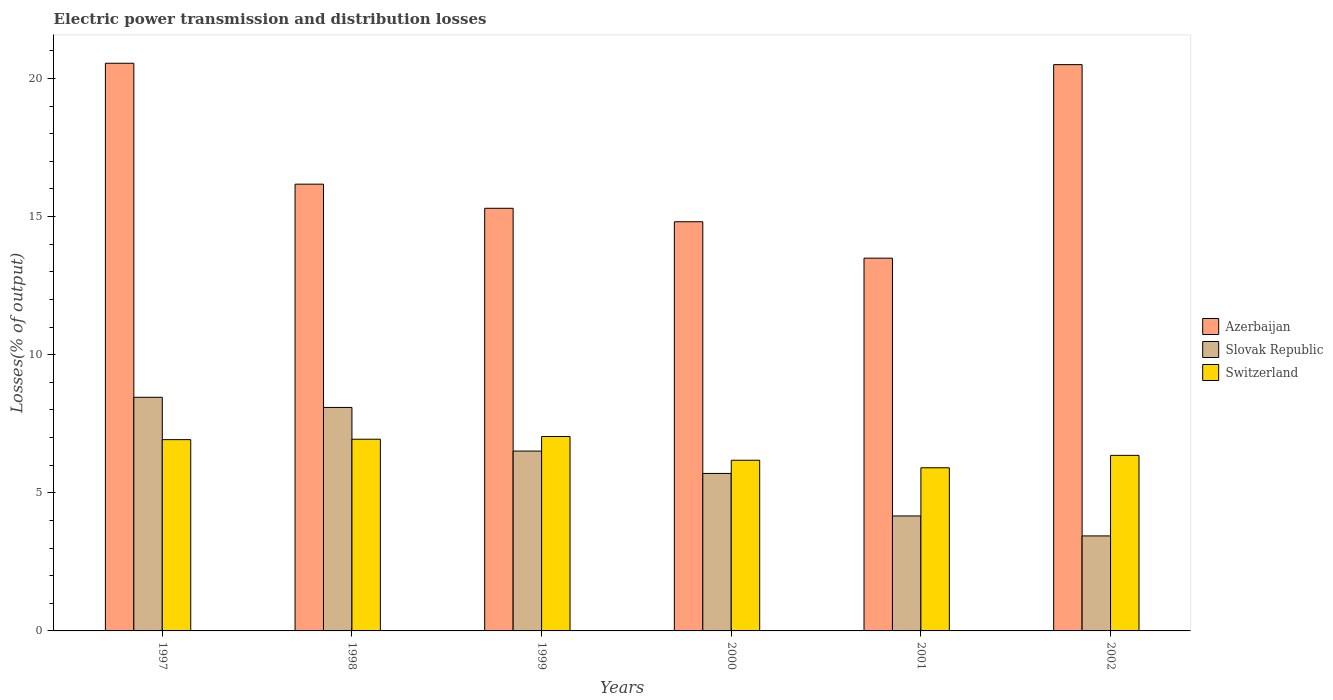Are the number of bars on each tick of the X-axis equal?
Provide a succinct answer. Yes. How many bars are there on the 2nd tick from the left?
Ensure brevity in your answer.  3. How many bars are there on the 6th tick from the right?
Your answer should be very brief. 3. What is the label of the 3rd group of bars from the left?
Give a very brief answer. 1999. What is the electric power transmission and distribution losses in Switzerland in 1999?
Make the answer very short. 7.04. Across all years, what is the maximum electric power transmission and distribution losses in Azerbaijan?
Your answer should be compact. 20.55. Across all years, what is the minimum electric power transmission and distribution losses in Switzerland?
Make the answer very short. 5.91. In which year was the electric power transmission and distribution losses in Switzerland maximum?
Your response must be concise. 1999. What is the total electric power transmission and distribution losses in Switzerland in the graph?
Your response must be concise. 39.34. What is the difference between the electric power transmission and distribution losses in Switzerland in 1998 and that in 2000?
Keep it short and to the point. 0.76. What is the difference between the electric power transmission and distribution losses in Switzerland in 2000 and the electric power transmission and distribution losses in Azerbaijan in 1998?
Keep it short and to the point. -9.99. What is the average electric power transmission and distribution losses in Azerbaijan per year?
Your answer should be very brief. 16.81. In the year 1998, what is the difference between the electric power transmission and distribution losses in Slovak Republic and electric power transmission and distribution losses in Switzerland?
Give a very brief answer. 1.15. What is the ratio of the electric power transmission and distribution losses in Azerbaijan in 2000 to that in 2002?
Give a very brief answer. 0.72. What is the difference between the highest and the second highest electric power transmission and distribution losses in Azerbaijan?
Your response must be concise. 0.05. What is the difference between the highest and the lowest electric power transmission and distribution losses in Slovak Republic?
Offer a very short reply. 5.02. In how many years, is the electric power transmission and distribution losses in Slovak Republic greater than the average electric power transmission and distribution losses in Slovak Republic taken over all years?
Your answer should be compact. 3. What does the 2nd bar from the left in 2002 represents?
Offer a very short reply. Slovak Republic. What does the 2nd bar from the right in 1997 represents?
Make the answer very short. Slovak Republic. Are all the bars in the graph horizontal?
Offer a very short reply. No. How many years are there in the graph?
Make the answer very short. 6. Does the graph contain any zero values?
Your answer should be very brief. No. How many legend labels are there?
Ensure brevity in your answer.  3. How are the legend labels stacked?
Your answer should be compact. Vertical. What is the title of the graph?
Your answer should be compact. Electric power transmission and distribution losses. Does "Cambodia" appear as one of the legend labels in the graph?
Provide a succinct answer. No. What is the label or title of the X-axis?
Your answer should be compact. Years. What is the label or title of the Y-axis?
Ensure brevity in your answer.  Losses(% of output). What is the Losses(% of output) in Azerbaijan in 1997?
Your response must be concise. 20.55. What is the Losses(% of output) in Slovak Republic in 1997?
Provide a short and direct response. 8.46. What is the Losses(% of output) of Switzerland in 1997?
Provide a succinct answer. 6.92. What is the Losses(% of output) in Azerbaijan in 1998?
Your answer should be very brief. 16.17. What is the Losses(% of output) of Slovak Republic in 1998?
Make the answer very short. 8.09. What is the Losses(% of output) in Switzerland in 1998?
Your answer should be very brief. 6.94. What is the Losses(% of output) in Azerbaijan in 1999?
Offer a very short reply. 15.3. What is the Losses(% of output) in Slovak Republic in 1999?
Provide a succinct answer. 6.51. What is the Losses(% of output) in Switzerland in 1999?
Your response must be concise. 7.04. What is the Losses(% of output) of Azerbaijan in 2000?
Make the answer very short. 14.81. What is the Losses(% of output) in Slovak Republic in 2000?
Provide a succinct answer. 5.7. What is the Losses(% of output) in Switzerland in 2000?
Your answer should be compact. 6.18. What is the Losses(% of output) of Azerbaijan in 2001?
Provide a short and direct response. 13.49. What is the Losses(% of output) of Slovak Republic in 2001?
Your response must be concise. 4.16. What is the Losses(% of output) in Switzerland in 2001?
Your response must be concise. 5.91. What is the Losses(% of output) in Azerbaijan in 2002?
Your response must be concise. 20.5. What is the Losses(% of output) of Slovak Republic in 2002?
Offer a terse response. 3.44. What is the Losses(% of output) in Switzerland in 2002?
Provide a succinct answer. 6.36. Across all years, what is the maximum Losses(% of output) in Azerbaijan?
Ensure brevity in your answer.  20.55. Across all years, what is the maximum Losses(% of output) of Slovak Republic?
Your answer should be very brief. 8.46. Across all years, what is the maximum Losses(% of output) in Switzerland?
Make the answer very short. 7.04. Across all years, what is the minimum Losses(% of output) in Azerbaijan?
Offer a very short reply. 13.49. Across all years, what is the minimum Losses(% of output) of Slovak Republic?
Make the answer very short. 3.44. Across all years, what is the minimum Losses(% of output) of Switzerland?
Provide a succinct answer. 5.91. What is the total Losses(% of output) of Azerbaijan in the graph?
Your answer should be compact. 100.84. What is the total Losses(% of output) of Slovak Republic in the graph?
Your response must be concise. 36.36. What is the total Losses(% of output) in Switzerland in the graph?
Provide a short and direct response. 39.34. What is the difference between the Losses(% of output) in Azerbaijan in 1997 and that in 1998?
Offer a terse response. 4.38. What is the difference between the Losses(% of output) in Slovak Republic in 1997 and that in 1998?
Offer a very short reply. 0.37. What is the difference between the Losses(% of output) of Switzerland in 1997 and that in 1998?
Provide a succinct answer. -0.02. What is the difference between the Losses(% of output) in Azerbaijan in 1997 and that in 1999?
Provide a short and direct response. 5.25. What is the difference between the Losses(% of output) in Slovak Republic in 1997 and that in 1999?
Keep it short and to the point. 1.95. What is the difference between the Losses(% of output) in Switzerland in 1997 and that in 1999?
Provide a succinct answer. -0.11. What is the difference between the Losses(% of output) of Azerbaijan in 1997 and that in 2000?
Offer a very short reply. 5.74. What is the difference between the Losses(% of output) of Slovak Republic in 1997 and that in 2000?
Your answer should be compact. 2.76. What is the difference between the Losses(% of output) in Switzerland in 1997 and that in 2000?
Offer a very short reply. 0.75. What is the difference between the Losses(% of output) in Azerbaijan in 1997 and that in 2001?
Your answer should be compact. 7.06. What is the difference between the Losses(% of output) of Slovak Republic in 1997 and that in 2001?
Your response must be concise. 4.3. What is the difference between the Losses(% of output) of Switzerland in 1997 and that in 2001?
Give a very brief answer. 1.02. What is the difference between the Losses(% of output) in Azerbaijan in 1997 and that in 2002?
Your answer should be very brief. 0.05. What is the difference between the Losses(% of output) in Slovak Republic in 1997 and that in 2002?
Your response must be concise. 5.02. What is the difference between the Losses(% of output) in Switzerland in 1997 and that in 2002?
Give a very brief answer. 0.57. What is the difference between the Losses(% of output) in Azerbaijan in 1998 and that in 1999?
Your response must be concise. 0.87. What is the difference between the Losses(% of output) of Slovak Republic in 1998 and that in 1999?
Give a very brief answer. 1.58. What is the difference between the Losses(% of output) in Switzerland in 1998 and that in 1999?
Your answer should be very brief. -0.1. What is the difference between the Losses(% of output) in Azerbaijan in 1998 and that in 2000?
Provide a short and direct response. 1.36. What is the difference between the Losses(% of output) in Slovak Republic in 1998 and that in 2000?
Keep it short and to the point. 2.39. What is the difference between the Losses(% of output) of Switzerland in 1998 and that in 2000?
Your answer should be compact. 0.76. What is the difference between the Losses(% of output) of Azerbaijan in 1998 and that in 2001?
Ensure brevity in your answer.  2.68. What is the difference between the Losses(% of output) of Slovak Republic in 1998 and that in 2001?
Keep it short and to the point. 3.93. What is the difference between the Losses(% of output) in Switzerland in 1998 and that in 2001?
Your answer should be compact. 1.03. What is the difference between the Losses(% of output) in Azerbaijan in 1998 and that in 2002?
Give a very brief answer. -4.33. What is the difference between the Losses(% of output) in Slovak Republic in 1998 and that in 2002?
Your answer should be compact. 4.65. What is the difference between the Losses(% of output) in Switzerland in 1998 and that in 2002?
Your answer should be very brief. 0.58. What is the difference between the Losses(% of output) in Azerbaijan in 1999 and that in 2000?
Provide a short and direct response. 0.49. What is the difference between the Losses(% of output) of Slovak Republic in 1999 and that in 2000?
Keep it short and to the point. 0.81. What is the difference between the Losses(% of output) of Switzerland in 1999 and that in 2000?
Offer a very short reply. 0.86. What is the difference between the Losses(% of output) in Azerbaijan in 1999 and that in 2001?
Offer a very short reply. 1.81. What is the difference between the Losses(% of output) of Slovak Republic in 1999 and that in 2001?
Your response must be concise. 2.35. What is the difference between the Losses(% of output) in Switzerland in 1999 and that in 2001?
Your response must be concise. 1.13. What is the difference between the Losses(% of output) of Azerbaijan in 1999 and that in 2002?
Your answer should be very brief. -5.2. What is the difference between the Losses(% of output) in Slovak Republic in 1999 and that in 2002?
Provide a short and direct response. 3.07. What is the difference between the Losses(% of output) in Switzerland in 1999 and that in 2002?
Provide a succinct answer. 0.68. What is the difference between the Losses(% of output) in Azerbaijan in 2000 and that in 2001?
Offer a terse response. 1.32. What is the difference between the Losses(% of output) of Slovak Republic in 2000 and that in 2001?
Provide a succinct answer. 1.54. What is the difference between the Losses(% of output) in Switzerland in 2000 and that in 2001?
Ensure brevity in your answer.  0.27. What is the difference between the Losses(% of output) of Azerbaijan in 2000 and that in 2002?
Your response must be concise. -5.69. What is the difference between the Losses(% of output) of Slovak Republic in 2000 and that in 2002?
Keep it short and to the point. 2.26. What is the difference between the Losses(% of output) of Switzerland in 2000 and that in 2002?
Ensure brevity in your answer.  -0.18. What is the difference between the Losses(% of output) in Azerbaijan in 2001 and that in 2002?
Provide a short and direct response. -7.01. What is the difference between the Losses(% of output) in Slovak Republic in 2001 and that in 2002?
Provide a short and direct response. 0.72. What is the difference between the Losses(% of output) in Switzerland in 2001 and that in 2002?
Give a very brief answer. -0.45. What is the difference between the Losses(% of output) of Azerbaijan in 1997 and the Losses(% of output) of Slovak Republic in 1998?
Give a very brief answer. 12.46. What is the difference between the Losses(% of output) of Azerbaijan in 1997 and the Losses(% of output) of Switzerland in 1998?
Your answer should be very brief. 13.61. What is the difference between the Losses(% of output) of Slovak Republic in 1997 and the Losses(% of output) of Switzerland in 1998?
Your response must be concise. 1.52. What is the difference between the Losses(% of output) of Azerbaijan in 1997 and the Losses(% of output) of Slovak Republic in 1999?
Provide a succinct answer. 14.04. What is the difference between the Losses(% of output) of Azerbaijan in 1997 and the Losses(% of output) of Switzerland in 1999?
Ensure brevity in your answer.  13.51. What is the difference between the Losses(% of output) of Slovak Republic in 1997 and the Losses(% of output) of Switzerland in 1999?
Ensure brevity in your answer.  1.42. What is the difference between the Losses(% of output) of Azerbaijan in 1997 and the Losses(% of output) of Slovak Republic in 2000?
Make the answer very short. 14.85. What is the difference between the Losses(% of output) in Azerbaijan in 1997 and the Losses(% of output) in Switzerland in 2000?
Make the answer very short. 14.37. What is the difference between the Losses(% of output) in Slovak Republic in 1997 and the Losses(% of output) in Switzerland in 2000?
Make the answer very short. 2.28. What is the difference between the Losses(% of output) of Azerbaijan in 1997 and the Losses(% of output) of Slovak Republic in 2001?
Make the answer very short. 16.39. What is the difference between the Losses(% of output) of Azerbaijan in 1997 and the Losses(% of output) of Switzerland in 2001?
Provide a succinct answer. 14.64. What is the difference between the Losses(% of output) of Slovak Republic in 1997 and the Losses(% of output) of Switzerland in 2001?
Your response must be concise. 2.55. What is the difference between the Losses(% of output) in Azerbaijan in 1997 and the Losses(% of output) in Slovak Republic in 2002?
Your answer should be very brief. 17.11. What is the difference between the Losses(% of output) of Azerbaijan in 1997 and the Losses(% of output) of Switzerland in 2002?
Your answer should be compact. 14.2. What is the difference between the Losses(% of output) in Slovak Republic in 1997 and the Losses(% of output) in Switzerland in 2002?
Offer a terse response. 2.1. What is the difference between the Losses(% of output) in Azerbaijan in 1998 and the Losses(% of output) in Slovak Republic in 1999?
Your response must be concise. 9.66. What is the difference between the Losses(% of output) in Azerbaijan in 1998 and the Losses(% of output) in Switzerland in 1999?
Keep it short and to the point. 9.14. What is the difference between the Losses(% of output) of Slovak Republic in 1998 and the Losses(% of output) of Switzerland in 1999?
Offer a very short reply. 1.05. What is the difference between the Losses(% of output) of Azerbaijan in 1998 and the Losses(% of output) of Slovak Republic in 2000?
Offer a very short reply. 10.47. What is the difference between the Losses(% of output) of Azerbaijan in 1998 and the Losses(% of output) of Switzerland in 2000?
Offer a very short reply. 9.99. What is the difference between the Losses(% of output) of Slovak Republic in 1998 and the Losses(% of output) of Switzerland in 2000?
Make the answer very short. 1.91. What is the difference between the Losses(% of output) of Azerbaijan in 1998 and the Losses(% of output) of Slovak Republic in 2001?
Your answer should be very brief. 12.01. What is the difference between the Losses(% of output) of Azerbaijan in 1998 and the Losses(% of output) of Switzerland in 2001?
Make the answer very short. 10.27. What is the difference between the Losses(% of output) of Slovak Republic in 1998 and the Losses(% of output) of Switzerland in 2001?
Provide a succinct answer. 2.18. What is the difference between the Losses(% of output) in Azerbaijan in 1998 and the Losses(% of output) in Slovak Republic in 2002?
Keep it short and to the point. 12.73. What is the difference between the Losses(% of output) of Azerbaijan in 1998 and the Losses(% of output) of Switzerland in 2002?
Offer a terse response. 9.82. What is the difference between the Losses(% of output) of Slovak Republic in 1998 and the Losses(% of output) of Switzerland in 2002?
Provide a succinct answer. 1.74. What is the difference between the Losses(% of output) of Azerbaijan in 1999 and the Losses(% of output) of Slovak Republic in 2000?
Make the answer very short. 9.6. What is the difference between the Losses(% of output) of Azerbaijan in 1999 and the Losses(% of output) of Switzerland in 2000?
Your answer should be compact. 9.12. What is the difference between the Losses(% of output) in Slovak Republic in 1999 and the Losses(% of output) in Switzerland in 2000?
Make the answer very short. 0.33. What is the difference between the Losses(% of output) in Azerbaijan in 1999 and the Losses(% of output) in Slovak Republic in 2001?
Offer a terse response. 11.14. What is the difference between the Losses(% of output) in Azerbaijan in 1999 and the Losses(% of output) in Switzerland in 2001?
Give a very brief answer. 9.39. What is the difference between the Losses(% of output) of Slovak Republic in 1999 and the Losses(% of output) of Switzerland in 2001?
Keep it short and to the point. 0.6. What is the difference between the Losses(% of output) in Azerbaijan in 1999 and the Losses(% of output) in Slovak Republic in 2002?
Offer a very short reply. 11.86. What is the difference between the Losses(% of output) of Azerbaijan in 1999 and the Losses(% of output) of Switzerland in 2002?
Offer a very short reply. 8.94. What is the difference between the Losses(% of output) in Slovak Republic in 1999 and the Losses(% of output) in Switzerland in 2002?
Your answer should be very brief. 0.16. What is the difference between the Losses(% of output) in Azerbaijan in 2000 and the Losses(% of output) in Slovak Republic in 2001?
Give a very brief answer. 10.65. What is the difference between the Losses(% of output) of Azerbaijan in 2000 and the Losses(% of output) of Switzerland in 2001?
Your answer should be very brief. 8.91. What is the difference between the Losses(% of output) in Slovak Republic in 2000 and the Losses(% of output) in Switzerland in 2001?
Make the answer very short. -0.2. What is the difference between the Losses(% of output) of Azerbaijan in 2000 and the Losses(% of output) of Slovak Republic in 2002?
Keep it short and to the point. 11.37. What is the difference between the Losses(% of output) of Azerbaijan in 2000 and the Losses(% of output) of Switzerland in 2002?
Offer a very short reply. 8.46. What is the difference between the Losses(% of output) of Slovak Republic in 2000 and the Losses(% of output) of Switzerland in 2002?
Your response must be concise. -0.65. What is the difference between the Losses(% of output) of Azerbaijan in 2001 and the Losses(% of output) of Slovak Republic in 2002?
Make the answer very short. 10.06. What is the difference between the Losses(% of output) in Azerbaijan in 2001 and the Losses(% of output) in Switzerland in 2002?
Keep it short and to the point. 7.14. What is the difference between the Losses(% of output) in Slovak Republic in 2001 and the Losses(% of output) in Switzerland in 2002?
Keep it short and to the point. -2.19. What is the average Losses(% of output) in Azerbaijan per year?
Keep it short and to the point. 16.81. What is the average Losses(% of output) of Slovak Republic per year?
Offer a very short reply. 6.06. What is the average Losses(% of output) of Switzerland per year?
Make the answer very short. 6.56. In the year 1997, what is the difference between the Losses(% of output) in Azerbaijan and Losses(% of output) in Slovak Republic?
Provide a short and direct response. 12.09. In the year 1997, what is the difference between the Losses(% of output) of Azerbaijan and Losses(% of output) of Switzerland?
Make the answer very short. 13.63. In the year 1997, what is the difference between the Losses(% of output) of Slovak Republic and Losses(% of output) of Switzerland?
Offer a terse response. 1.53. In the year 1998, what is the difference between the Losses(% of output) of Azerbaijan and Losses(% of output) of Slovak Republic?
Offer a very short reply. 8.08. In the year 1998, what is the difference between the Losses(% of output) in Azerbaijan and Losses(% of output) in Switzerland?
Ensure brevity in your answer.  9.23. In the year 1998, what is the difference between the Losses(% of output) of Slovak Republic and Losses(% of output) of Switzerland?
Make the answer very short. 1.15. In the year 1999, what is the difference between the Losses(% of output) in Azerbaijan and Losses(% of output) in Slovak Republic?
Your response must be concise. 8.79. In the year 1999, what is the difference between the Losses(% of output) in Azerbaijan and Losses(% of output) in Switzerland?
Ensure brevity in your answer.  8.26. In the year 1999, what is the difference between the Losses(% of output) in Slovak Republic and Losses(% of output) in Switzerland?
Offer a very short reply. -0.53. In the year 2000, what is the difference between the Losses(% of output) in Azerbaijan and Losses(% of output) in Slovak Republic?
Offer a terse response. 9.11. In the year 2000, what is the difference between the Losses(% of output) of Azerbaijan and Losses(% of output) of Switzerland?
Offer a terse response. 8.63. In the year 2000, what is the difference between the Losses(% of output) of Slovak Republic and Losses(% of output) of Switzerland?
Your response must be concise. -0.48. In the year 2001, what is the difference between the Losses(% of output) of Azerbaijan and Losses(% of output) of Slovak Republic?
Keep it short and to the point. 9.33. In the year 2001, what is the difference between the Losses(% of output) of Azerbaijan and Losses(% of output) of Switzerland?
Ensure brevity in your answer.  7.59. In the year 2001, what is the difference between the Losses(% of output) of Slovak Republic and Losses(% of output) of Switzerland?
Provide a short and direct response. -1.74. In the year 2002, what is the difference between the Losses(% of output) of Azerbaijan and Losses(% of output) of Slovak Republic?
Your response must be concise. 17.06. In the year 2002, what is the difference between the Losses(% of output) of Azerbaijan and Losses(% of output) of Switzerland?
Your response must be concise. 14.15. In the year 2002, what is the difference between the Losses(% of output) in Slovak Republic and Losses(% of output) in Switzerland?
Keep it short and to the point. -2.92. What is the ratio of the Losses(% of output) of Azerbaijan in 1997 to that in 1998?
Offer a very short reply. 1.27. What is the ratio of the Losses(% of output) in Slovak Republic in 1997 to that in 1998?
Make the answer very short. 1.05. What is the ratio of the Losses(% of output) of Azerbaijan in 1997 to that in 1999?
Make the answer very short. 1.34. What is the ratio of the Losses(% of output) in Slovak Republic in 1997 to that in 1999?
Your response must be concise. 1.3. What is the ratio of the Losses(% of output) in Switzerland in 1997 to that in 1999?
Provide a succinct answer. 0.98. What is the ratio of the Losses(% of output) of Azerbaijan in 1997 to that in 2000?
Give a very brief answer. 1.39. What is the ratio of the Losses(% of output) of Slovak Republic in 1997 to that in 2000?
Your response must be concise. 1.48. What is the ratio of the Losses(% of output) of Switzerland in 1997 to that in 2000?
Offer a very short reply. 1.12. What is the ratio of the Losses(% of output) in Azerbaijan in 1997 to that in 2001?
Offer a very short reply. 1.52. What is the ratio of the Losses(% of output) of Slovak Republic in 1997 to that in 2001?
Give a very brief answer. 2.03. What is the ratio of the Losses(% of output) of Switzerland in 1997 to that in 2001?
Offer a very short reply. 1.17. What is the ratio of the Losses(% of output) in Slovak Republic in 1997 to that in 2002?
Your response must be concise. 2.46. What is the ratio of the Losses(% of output) of Switzerland in 1997 to that in 2002?
Provide a succinct answer. 1.09. What is the ratio of the Losses(% of output) in Azerbaijan in 1998 to that in 1999?
Ensure brevity in your answer.  1.06. What is the ratio of the Losses(% of output) of Slovak Republic in 1998 to that in 1999?
Provide a short and direct response. 1.24. What is the ratio of the Losses(% of output) of Switzerland in 1998 to that in 1999?
Your response must be concise. 0.99. What is the ratio of the Losses(% of output) in Azerbaijan in 1998 to that in 2000?
Your answer should be compact. 1.09. What is the ratio of the Losses(% of output) in Slovak Republic in 1998 to that in 2000?
Your answer should be very brief. 1.42. What is the ratio of the Losses(% of output) in Switzerland in 1998 to that in 2000?
Provide a short and direct response. 1.12. What is the ratio of the Losses(% of output) of Azerbaijan in 1998 to that in 2001?
Offer a very short reply. 1.2. What is the ratio of the Losses(% of output) of Slovak Republic in 1998 to that in 2001?
Give a very brief answer. 1.94. What is the ratio of the Losses(% of output) in Switzerland in 1998 to that in 2001?
Offer a very short reply. 1.18. What is the ratio of the Losses(% of output) of Azerbaijan in 1998 to that in 2002?
Make the answer very short. 0.79. What is the ratio of the Losses(% of output) of Slovak Republic in 1998 to that in 2002?
Your answer should be very brief. 2.35. What is the ratio of the Losses(% of output) in Switzerland in 1998 to that in 2002?
Give a very brief answer. 1.09. What is the ratio of the Losses(% of output) of Azerbaijan in 1999 to that in 2000?
Your answer should be very brief. 1.03. What is the ratio of the Losses(% of output) of Slovak Republic in 1999 to that in 2000?
Provide a succinct answer. 1.14. What is the ratio of the Losses(% of output) of Switzerland in 1999 to that in 2000?
Ensure brevity in your answer.  1.14. What is the ratio of the Losses(% of output) of Azerbaijan in 1999 to that in 2001?
Your answer should be compact. 1.13. What is the ratio of the Losses(% of output) in Slovak Republic in 1999 to that in 2001?
Your answer should be compact. 1.56. What is the ratio of the Losses(% of output) in Switzerland in 1999 to that in 2001?
Offer a very short reply. 1.19. What is the ratio of the Losses(% of output) in Azerbaijan in 1999 to that in 2002?
Provide a short and direct response. 0.75. What is the ratio of the Losses(% of output) in Slovak Republic in 1999 to that in 2002?
Offer a terse response. 1.89. What is the ratio of the Losses(% of output) of Switzerland in 1999 to that in 2002?
Keep it short and to the point. 1.11. What is the ratio of the Losses(% of output) of Azerbaijan in 2000 to that in 2001?
Provide a short and direct response. 1.1. What is the ratio of the Losses(% of output) in Slovak Republic in 2000 to that in 2001?
Give a very brief answer. 1.37. What is the ratio of the Losses(% of output) in Switzerland in 2000 to that in 2001?
Your answer should be very brief. 1.05. What is the ratio of the Losses(% of output) in Azerbaijan in 2000 to that in 2002?
Give a very brief answer. 0.72. What is the ratio of the Losses(% of output) in Slovak Republic in 2000 to that in 2002?
Provide a succinct answer. 1.66. What is the ratio of the Losses(% of output) in Switzerland in 2000 to that in 2002?
Your response must be concise. 0.97. What is the ratio of the Losses(% of output) of Azerbaijan in 2001 to that in 2002?
Provide a short and direct response. 0.66. What is the ratio of the Losses(% of output) of Slovak Republic in 2001 to that in 2002?
Provide a short and direct response. 1.21. What is the ratio of the Losses(% of output) of Switzerland in 2001 to that in 2002?
Your answer should be compact. 0.93. What is the difference between the highest and the second highest Losses(% of output) in Azerbaijan?
Your answer should be very brief. 0.05. What is the difference between the highest and the second highest Losses(% of output) of Slovak Republic?
Keep it short and to the point. 0.37. What is the difference between the highest and the second highest Losses(% of output) in Switzerland?
Give a very brief answer. 0.1. What is the difference between the highest and the lowest Losses(% of output) of Azerbaijan?
Provide a succinct answer. 7.06. What is the difference between the highest and the lowest Losses(% of output) in Slovak Republic?
Your response must be concise. 5.02. What is the difference between the highest and the lowest Losses(% of output) in Switzerland?
Give a very brief answer. 1.13. 